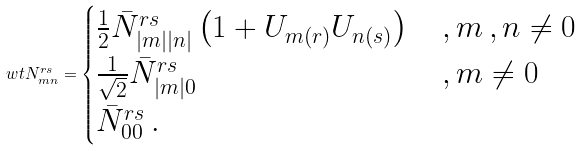Convert formula to latex. <formula><loc_0><loc_0><loc_500><loc_500>\ w t { N } ^ { r s } _ { m n } = \begin{cases} \frac { 1 } { 2 } \bar { N } ^ { r s } _ { | m | | n | } \left ( 1 + U _ { m ( r ) } U _ { n ( s ) } \right ) & \, , m \, , n \neq 0 \\ \frac { 1 } { \sqrt { 2 } } \bar { N } ^ { r s } _ { | m | 0 } & \, , m \neq 0 \\ \bar { N } ^ { r s } _ { 0 0 } \, . \end{cases}</formula> 